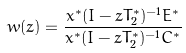Convert formula to latex. <formula><loc_0><loc_0><loc_500><loc_500>w ( z ) = \frac { x ^ { * } ( I - z T _ { 2 } ^ { * } ) ^ { - 1 } E ^ { * } } { x ^ { * } ( I - z T _ { 2 } ^ { * } ) ^ { - 1 } C ^ { * } }</formula> 